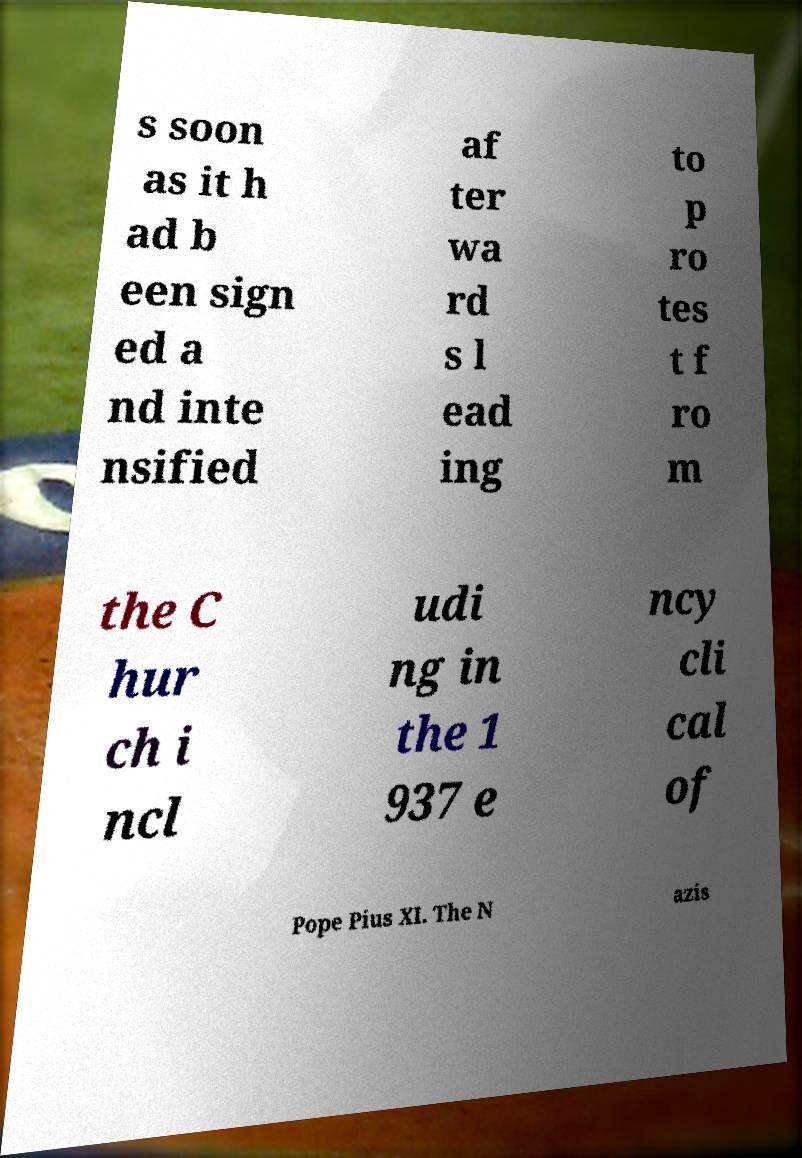Please read and relay the text visible in this image. What does it say? s soon as it h ad b een sign ed a nd inte nsified af ter wa rd s l ead ing to p ro tes t f ro m the C hur ch i ncl udi ng in the 1 937 e ncy cli cal of Pope Pius XI. The N azis 